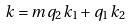<formula> <loc_0><loc_0><loc_500><loc_500>k = m q _ { 2 } k _ { 1 } + q _ { 1 } k _ { 2 }</formula> 